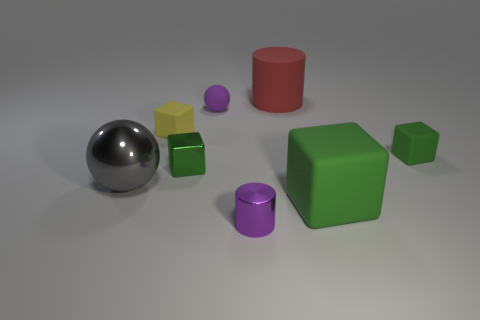What is the color of the metal object behind the sphere that is left of the tiny shiny block?
Provide a succinct answer. Green. How many other objects are the same material as the small yellow block?
Your response must be concise. 4. What number of other things are the same color as the metallic cylinder?
Offer a terse response. 1. What is the big thing to the left of the shiny object that is in front of the metallic sphere made of?
Offer a terse response. Metal. Is there a big purple sphere?
Keep it short and to the point. No. What size is the rubber cube to the left of the purple matte object that is on the right side of the small yellow rubber thing?
Your answer should be very brief. Small. Is the number of metallic cylinders in front of the large shiny ball greater than the number of tiny yellow matte objects that are in front of the large block?
Make the answer very short. Yes. How many cubes are purple objects or gray metallic things?
Give a very brief answer. 0. Is the shape of the tiny purple thing left of the small cylinder the same as  the big metallic object?
Give a very brief answer. Yes. What is the color of the rubber ball?
Your answer should be compact. Purple. 